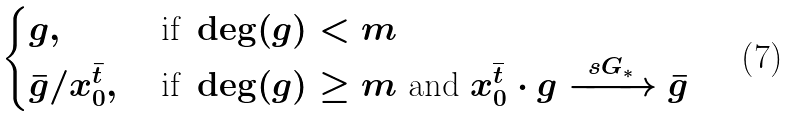<formula> <loc_0><loc_0><loc_500><loc_500>\begin{cases} g , & \text { if } \deg ( g ) < m \\ \bar { g } / x _ { 0 } ^ { \bar { t } } , & \text { if } \deg ( g ) \geq m \text { and } x _ { 0 } ^ { \overline { t } } \cdot g \xrightarrow { \ s G _ { \ast } \ } { \bar { g } } \end{cases}</formula> 